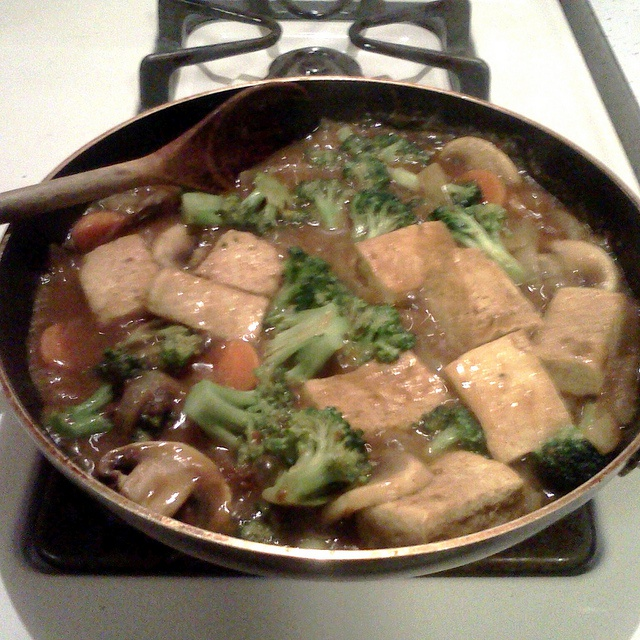Describe the objects in this image and their specific colors. I can see bowl in beige, black, tan, olive, and gray tones, oven in black, ivory, gray, and darkgray tones, spoon in beige, black, maroon, and gray tones, broccoli in beige, olive, and black tones, and broccoli in beige, olive, and black tones in this image. 